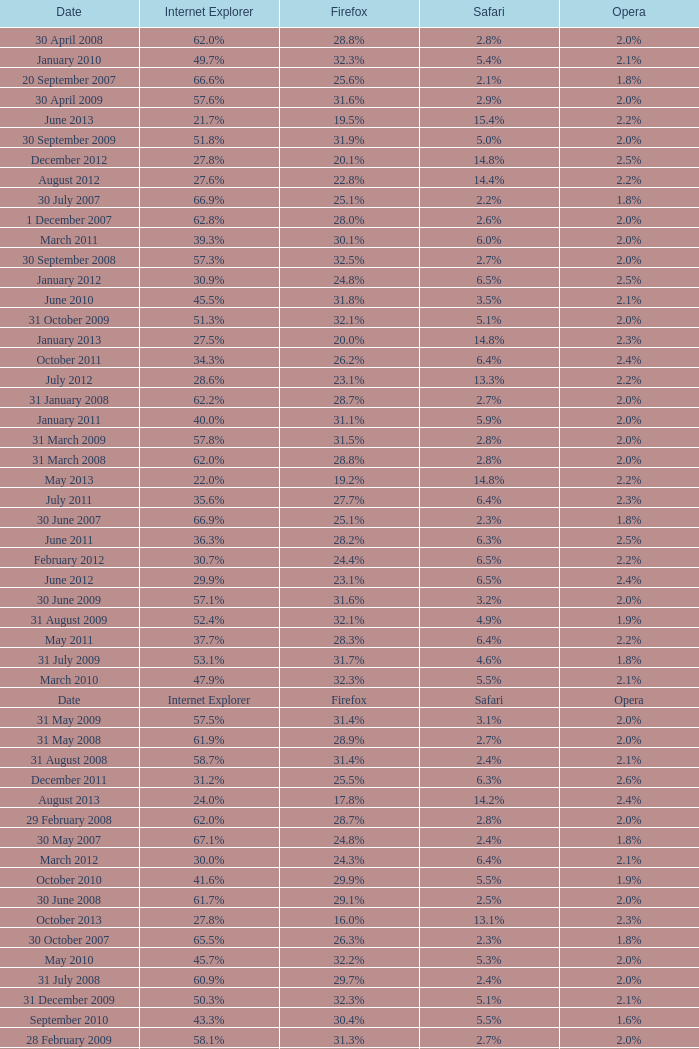What is the firefox value with a 1.9% safari? 31.4%. 